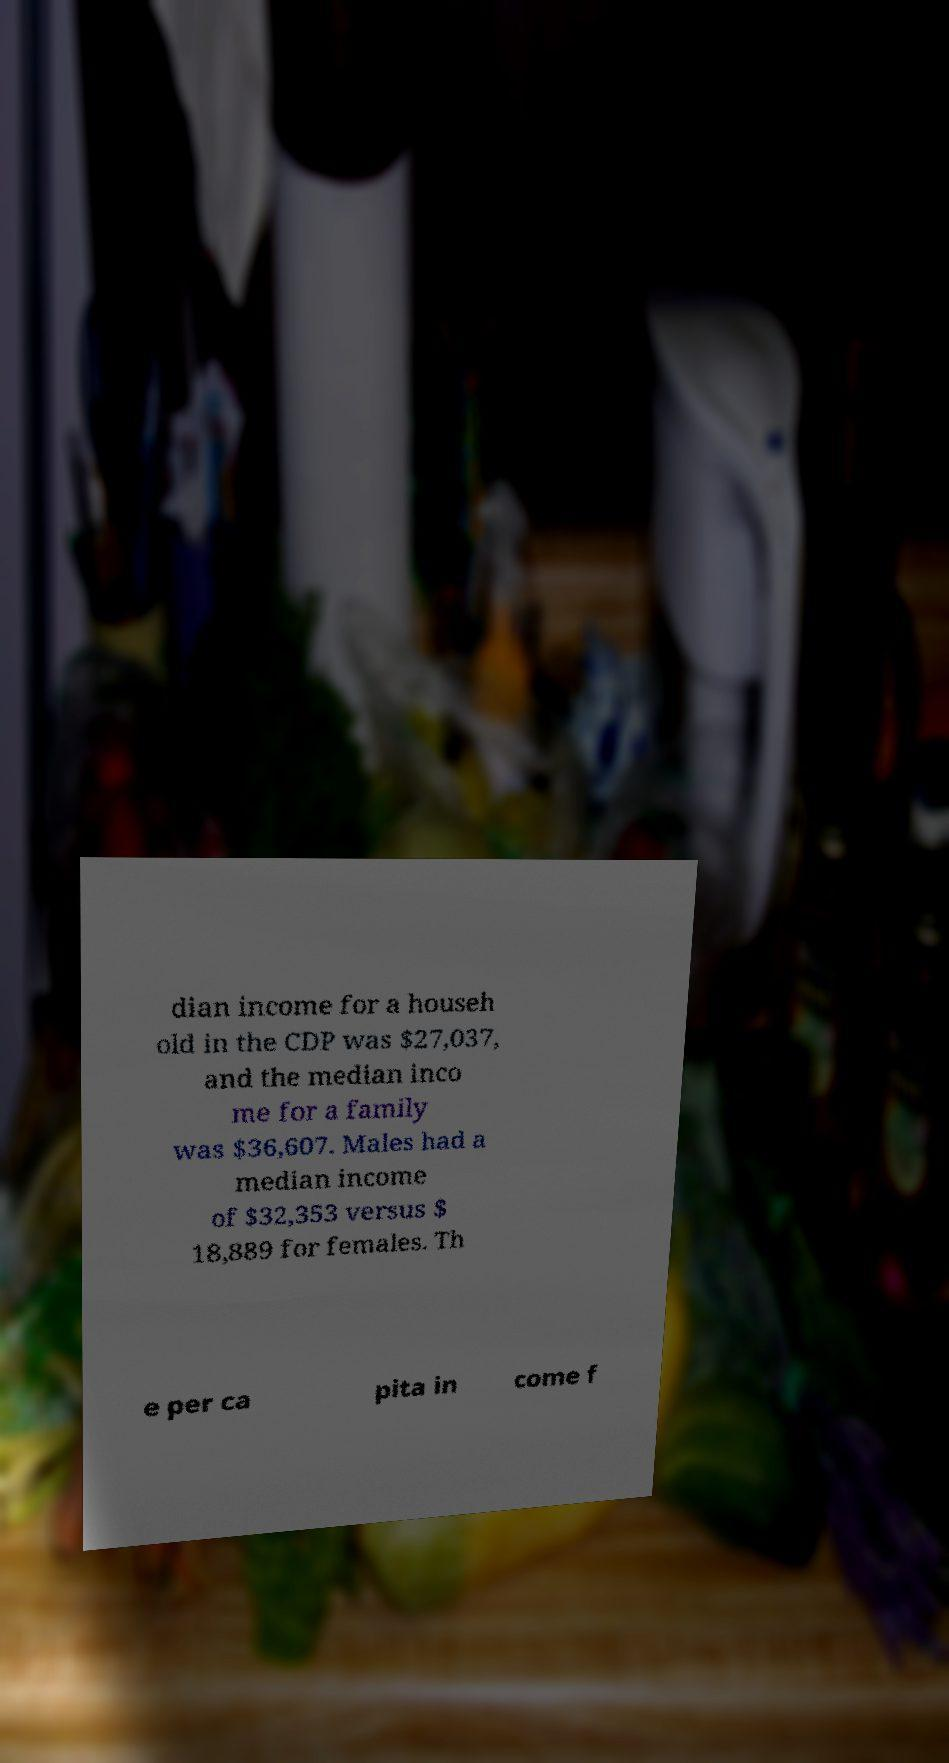I need the written content from this picture converted into text. Can you do that? dian income for a househ old in the CDP was $27,037, and the median inco me for a family was $36,607. Males had a median income of $32,353 versus $ 18,889 for females. Th e per ca pita in come f 